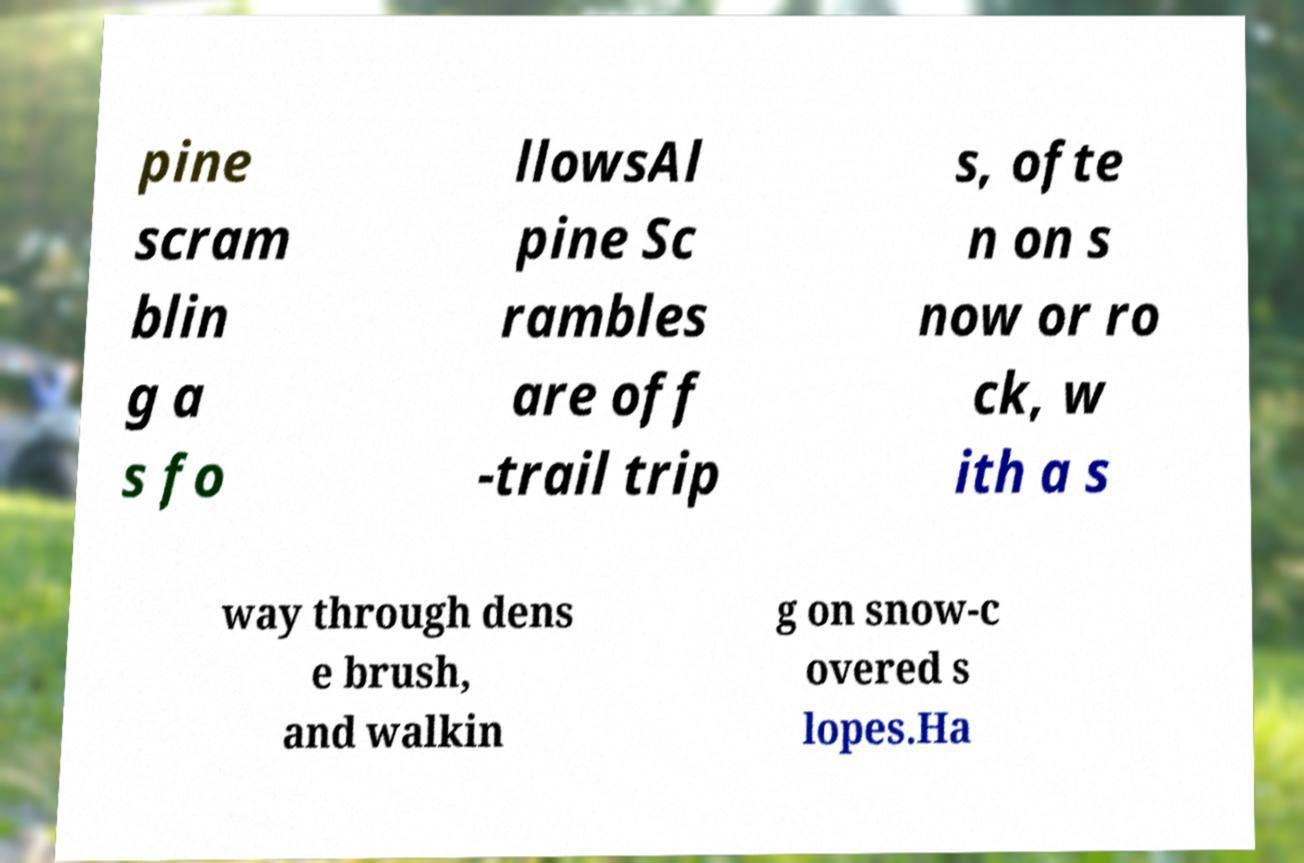Please read and relay the text visible in this image. What does it say? pine scram blin g a s fo llowsAl pine Sc rambles are off -trail trip s, ofte n on s now or ro ck, w ith a s way through dens e brush, and walkin g on snow-c overed s lopes.Ha 